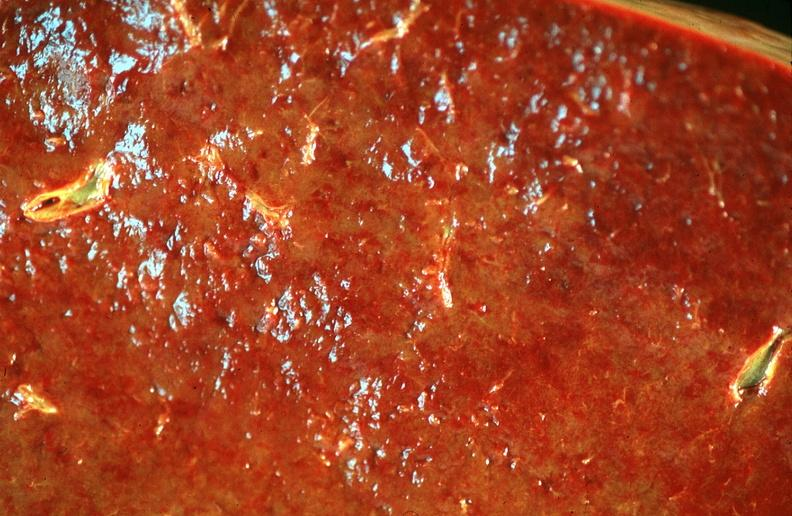does pus in test tube show spleen, chronic congestion due to portal hypertension from cirrhosis, hcv?
Answer the question using a single word or phrase. No 